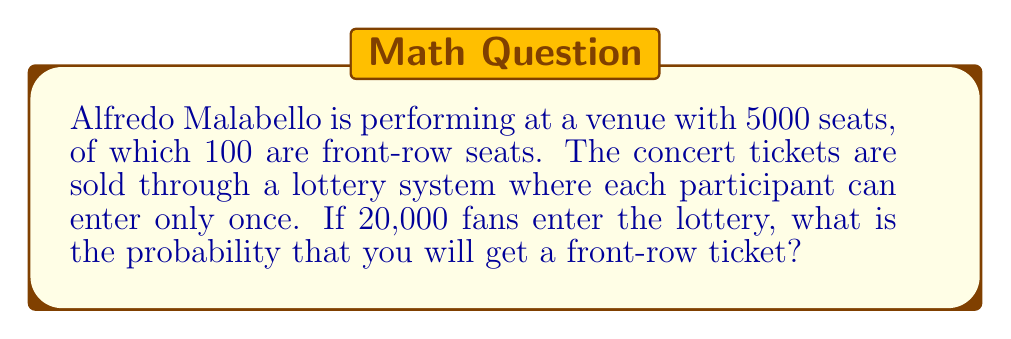Could you help me with this problem? Let's approach this step-by-step:

1) First, we need to calculate the probability of getting any ticket at all. 
   There are 5000 seats available and 20,000 participants.
   
   $P(\text{getting a ticket}) = \frac{5000}{20000} = \frac{1}{4} = 0.25$

2) Now, given that you got a ticket, we need to calculate the probability that it's a front-row ticket.
   There are 100 front-row seats out of 5000 total seats.
   
   $P(\text{front-row} | \text{got a ticket}) = \frac{100}{5000} = \frac{1}{50} = 0.02$

3) The probability of getting a front-row ticket is the product of these two probabilities:

   $P(\text{front-row ticket}) = P(\text{getting a ticket}) \times P(\text{front-row} | \text{got a ticket})$

   $P(\text{front-row ticket}) = 0.25 \times 0.02 = 0.005$

4) We can also express this as a fraction:

   $P(\text{front-row ticket}) = \frac{1}{4} \times \frac{1}{50} = \frac{1}{200}$

Therefore, the probability of getting a front-row ticket is 0.005 or $\frac{1}{200}$.
Answer: $\frac{1}{200}$ 